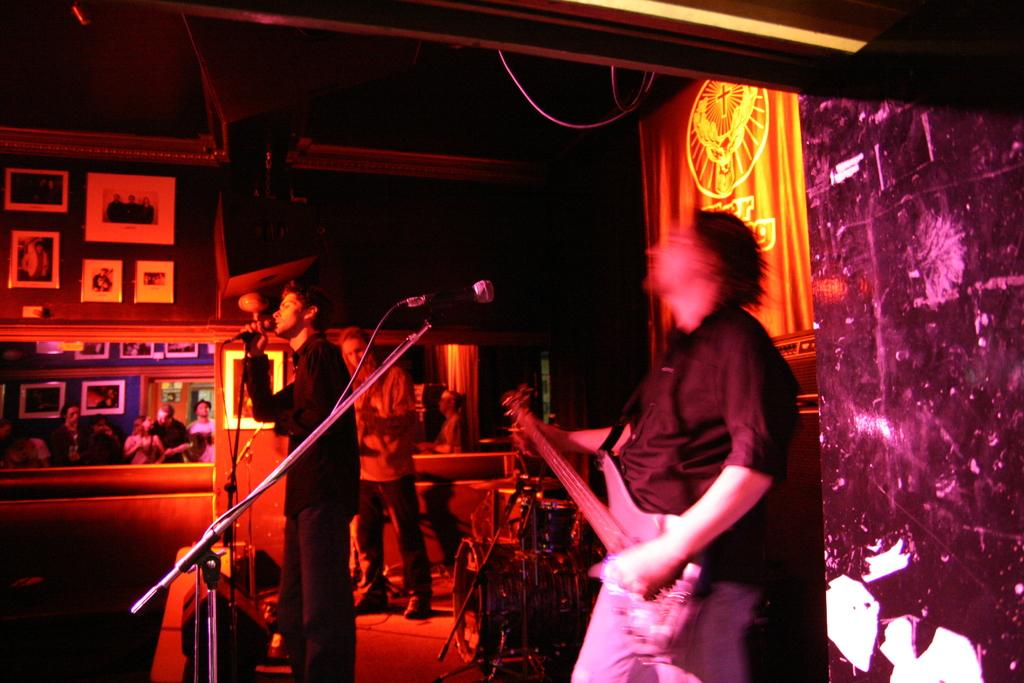How many people can be seen in the image? There are three persons in the image. What are two of the persons doing? Two of the persons are holding musical instruments. What is the third person holding? The third person is holding a microphone. Are there any other people visible in the image? Yes, there are additional people visible in the image. What type of soda is being poured into the microphone in the image? There is no soda or pouring action present in the image. What type of trousers is the person holding the microphone wearing? The image does not provide enough detail to determine the type of trousers the person is wearing. 